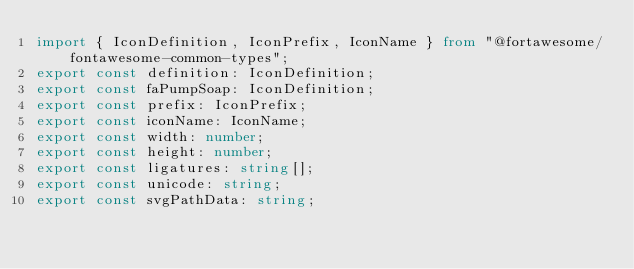<code> <loc_0><loc_0><loc_500><loc_500><_TypeScript_>import { IconDefinition, IconPrefix, IconName } from "@fortawesome/fontawesome-common-types";
export const definition: IconDefinition;
export const faPumpSoap: IconDefinition;
export const prefix: IconPrefix;
export const iconName: IconName;
export const width: number;
export const height: number;
export const ligatures: string[];
export const unicode: string;
export const svgPathData: string;</code> 